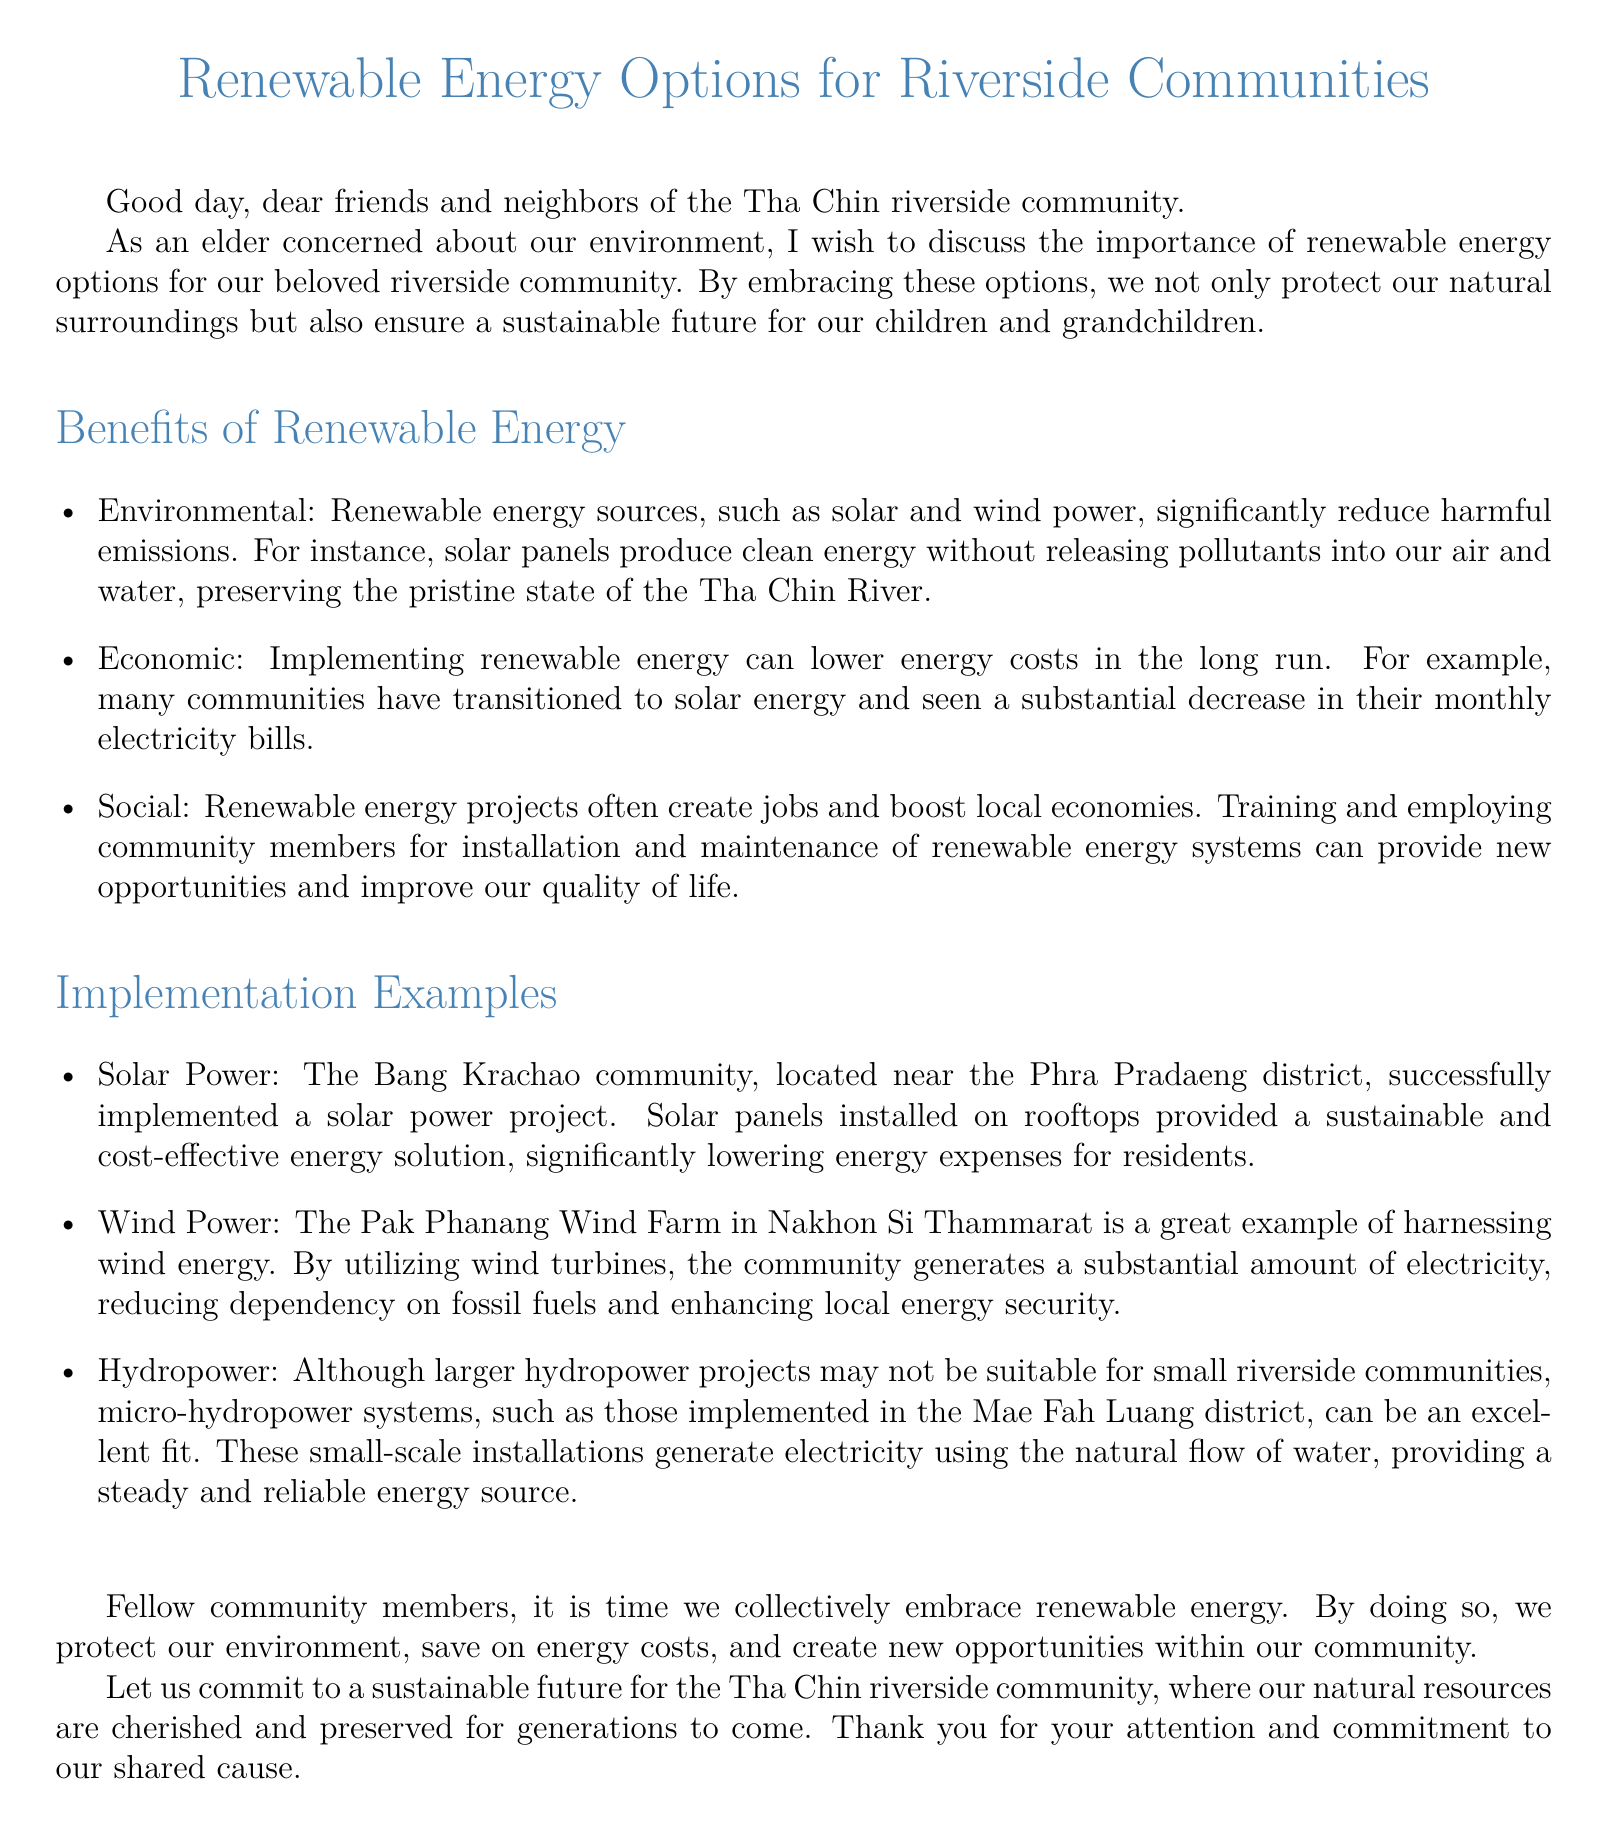What is the main focus of the document? The document discusses renewable energy options specifically for riverside communities, emphasizing their importance and benefits.
Answer: renewable energy options Which community is mentioned as having a solar power project? The document states that the Bang Krachao community successfully implemented a solar power project.
Answer: Bang Krachao community What type of renewable energy project reduces monthly electricity bills? The document mentions solar energy as a renewable option that can lower energy costs for residents in the long run.
Answer: solar energy What is an economic benefit of renewable energy mentioned in the document? The document states that implementing renewable energy can lead to a substantial decrease in monthly electricity bills.
Answer: lower energy costs What specific renewable energy option is highlighted for small riverside communities? The document refers to micro-hydropower systems as suitable for small riverside communities.
Answer: micro-hydropower systems How many benefits of renewable energy are listed in the document? The document outlines three main benefits of renewable energy: environmental, economic, and social.
Answer: three What is the key environmental benefit mentioned for solar panels? The document explains that solar panels produce clean energy without releasing pollutants, which helps preserve the environment.
Answer: preserve the environment Which type of renewable energy project is implemented in the Pak Phanang area? The document explains that a wind farm utilizes wind energy to generate electricity.
Answer: wind energy 